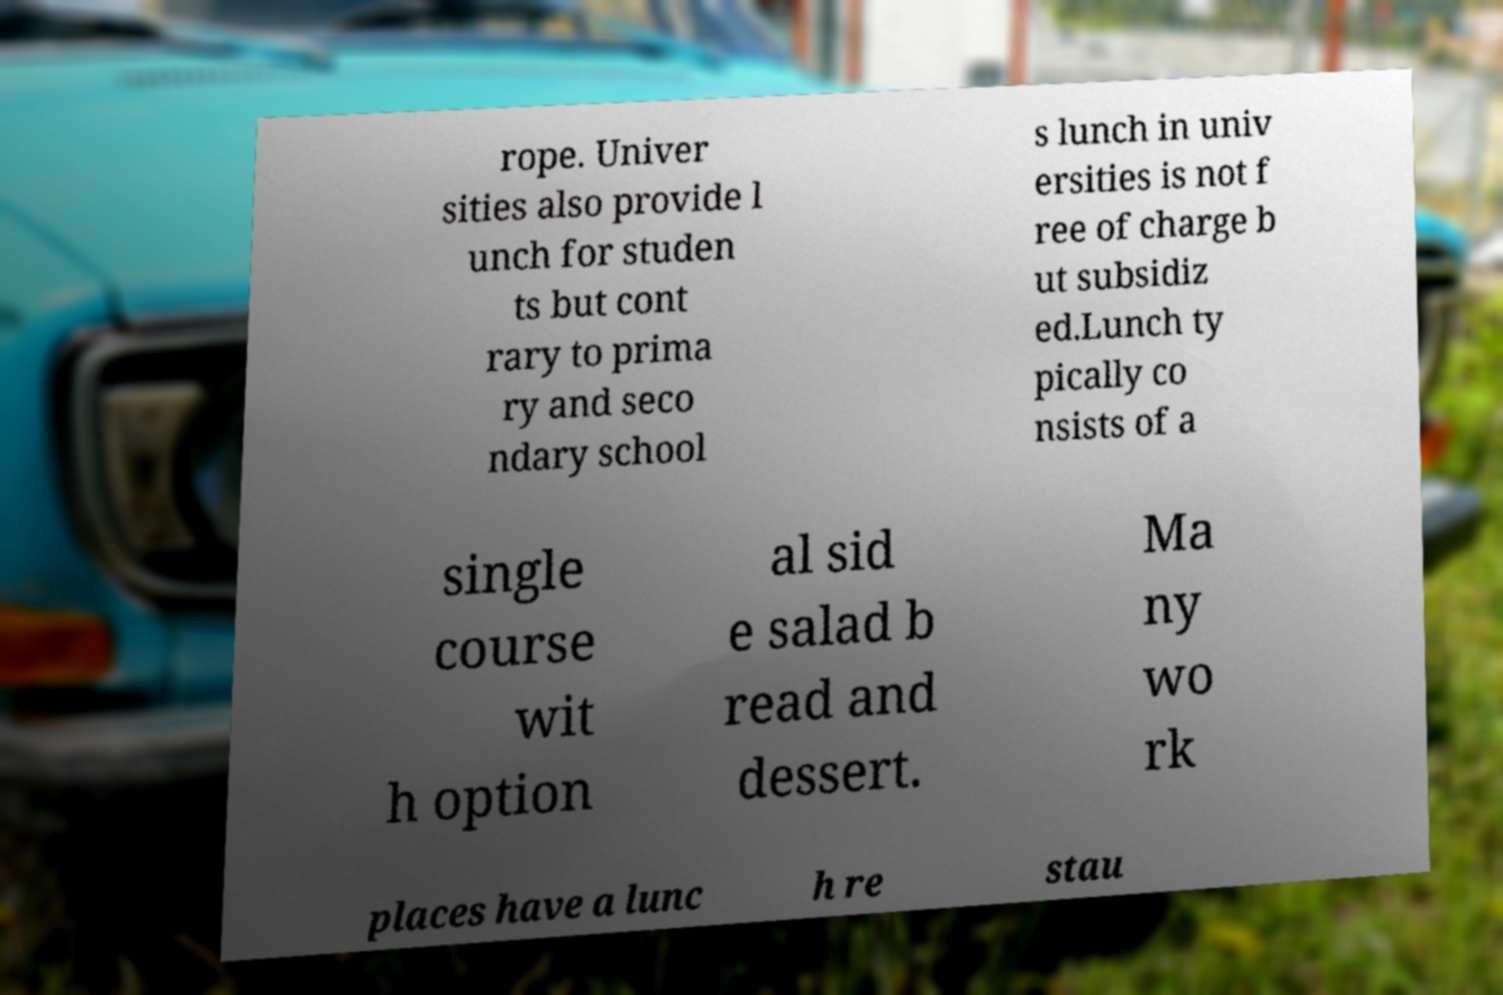Please identify and transcribe the text found in this image. rope. Univer sities also provide l unch for studen ts but cont rary to prima ry and seco ndary school s lunch in univ ersities is not f ree of charge b ut subsidiz ed.Lunch ty pically co nsists of a single course wit h option al sid e salad b read and dessert. Ma ny wo rk places have a lunc h re stau 